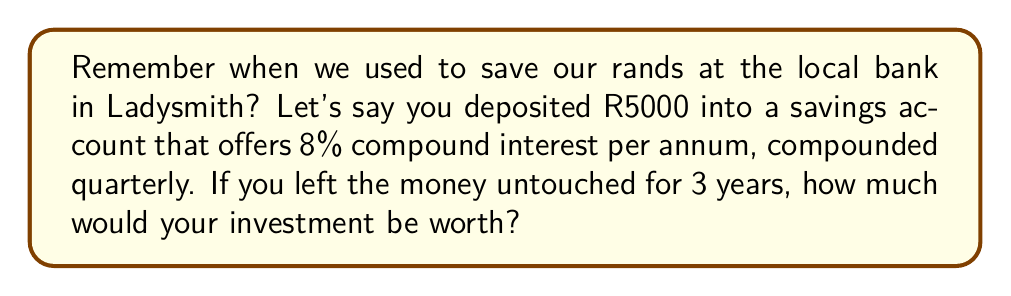Show me your answer to this math problem. Let's approach this step-by-step using the compound interest formula:

$$A = P(1 + \frac{r}{n})^{nt}$$

Where:
$A$ = final amount
$P$ = principal (initial investment)
$r$ = annual interest rate (in decimal form)
$n$ = number of times interest is compounded per year
$t$ = number of years

Given:
$P = 5000$ rands
$r = 8\% = 0.08$
$n = 4$ (compounded quarterly)
$t = 3$ years

Let's plug these values into our formula:

$$A = 5000(1 + \frac{0.08}{4})^{4 \times 3}$$

$$A = 5000(1 + 0.02)^{12}$$

$$A = 5000(1.02)^{12}$$

Now, let's calculate:

$$A = 5000 \times 1.268241795$$

$$A = 6341.20897$$

Rounding to the nearest cent (as is customary with currency):

$$A = 6341.21$$ rands
Answer: R6341.21 